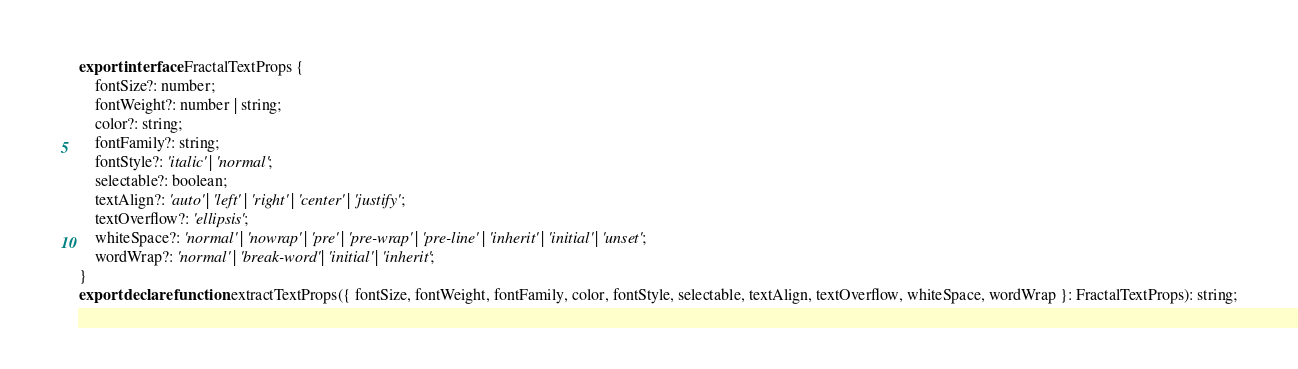<code> <loc_0><loc_0><loc_500><loc_500><_TypeScript_>export interface FractalTextProps {
    fontSize?: number;
    fontWeight?: number | string;
    color?: string;
    fontFamily?: string;
    fontStyle?: 'italic' | 'normal';
    selectable?: boolean;
    textAlign?: 'auto' | 'left' | 'right' | 'center' | 'justify';
    textOverflow?: 'ellipsis';
    whiteSpace?: 'normal' | 'nowrap' | 'pre' | 'pre-wrap' | 'pre-line' | 'inherit' | 'initial' | 'unset';
    wordWrap?: 'normal' | 'break-word' | 'initial' | 'inherit';
}
export declare function extractTextProps({ fontSize, fontWeight, fontFamily, color, fontStyle, selectable, textAlign, textOverflow, whiteSpace, wordWrap }: FractalTextProps): string;
</code> 